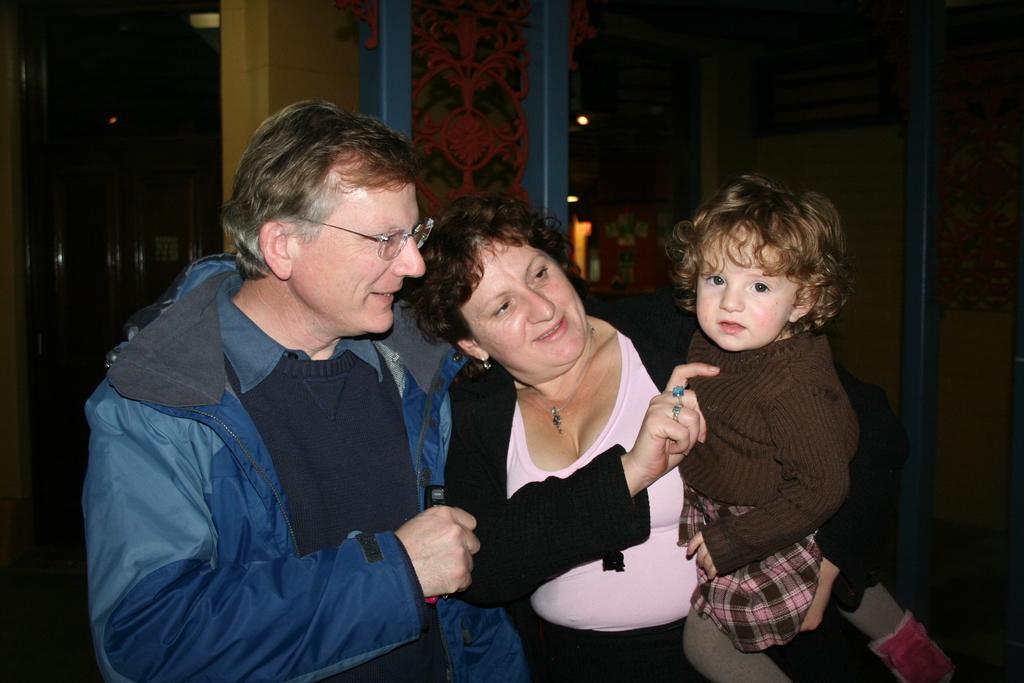Can you describe this image briefly? There is a man wearing jacket and specs. Near to him there is a lady holding a child. In the back there is a wall with some decorations. 